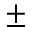<formula> <loc_0><loc_0><loc_500><loc_500>\pm</formula> 